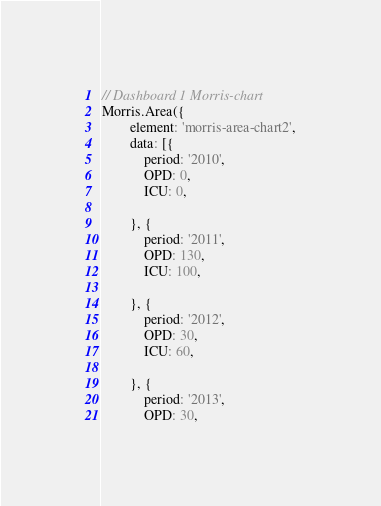Convert code to text. <code><loc_0><loc_0><loc_500><loc_500><_JavaScript_>

// Dashboard 1 Morris-chart
Morris.Area({
        element: 'morris-area-chart2',
        data: [{
            period: '2010',
            OPD: 0,
            ICU: 0,
            
        }, {
            period: '2011',
            OPD: 130,
            ICU: 100,
            
        }, {
            period: '2012',
            OPD: 30,
            ICU: 60,
            
        }, {
            period: '2013',
            OPD: 30,</code> 